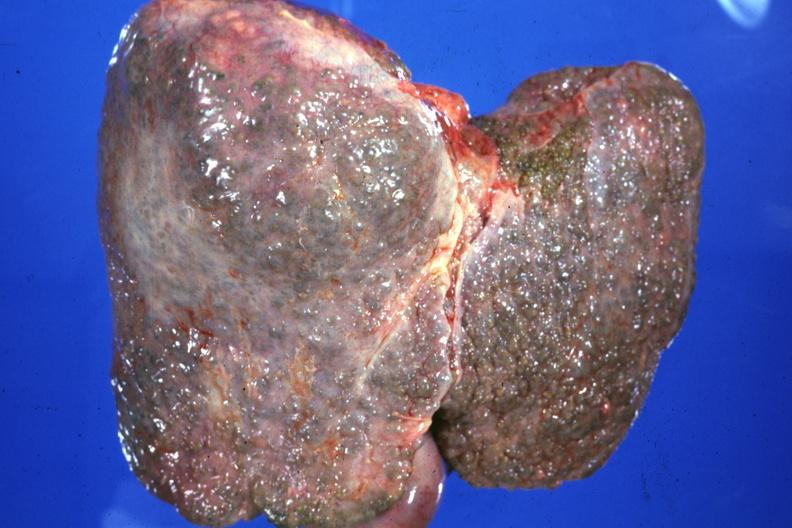does this image show external view typical alcoholic type cirrhosis?
Answer the question using a single word or phrase. Yes 